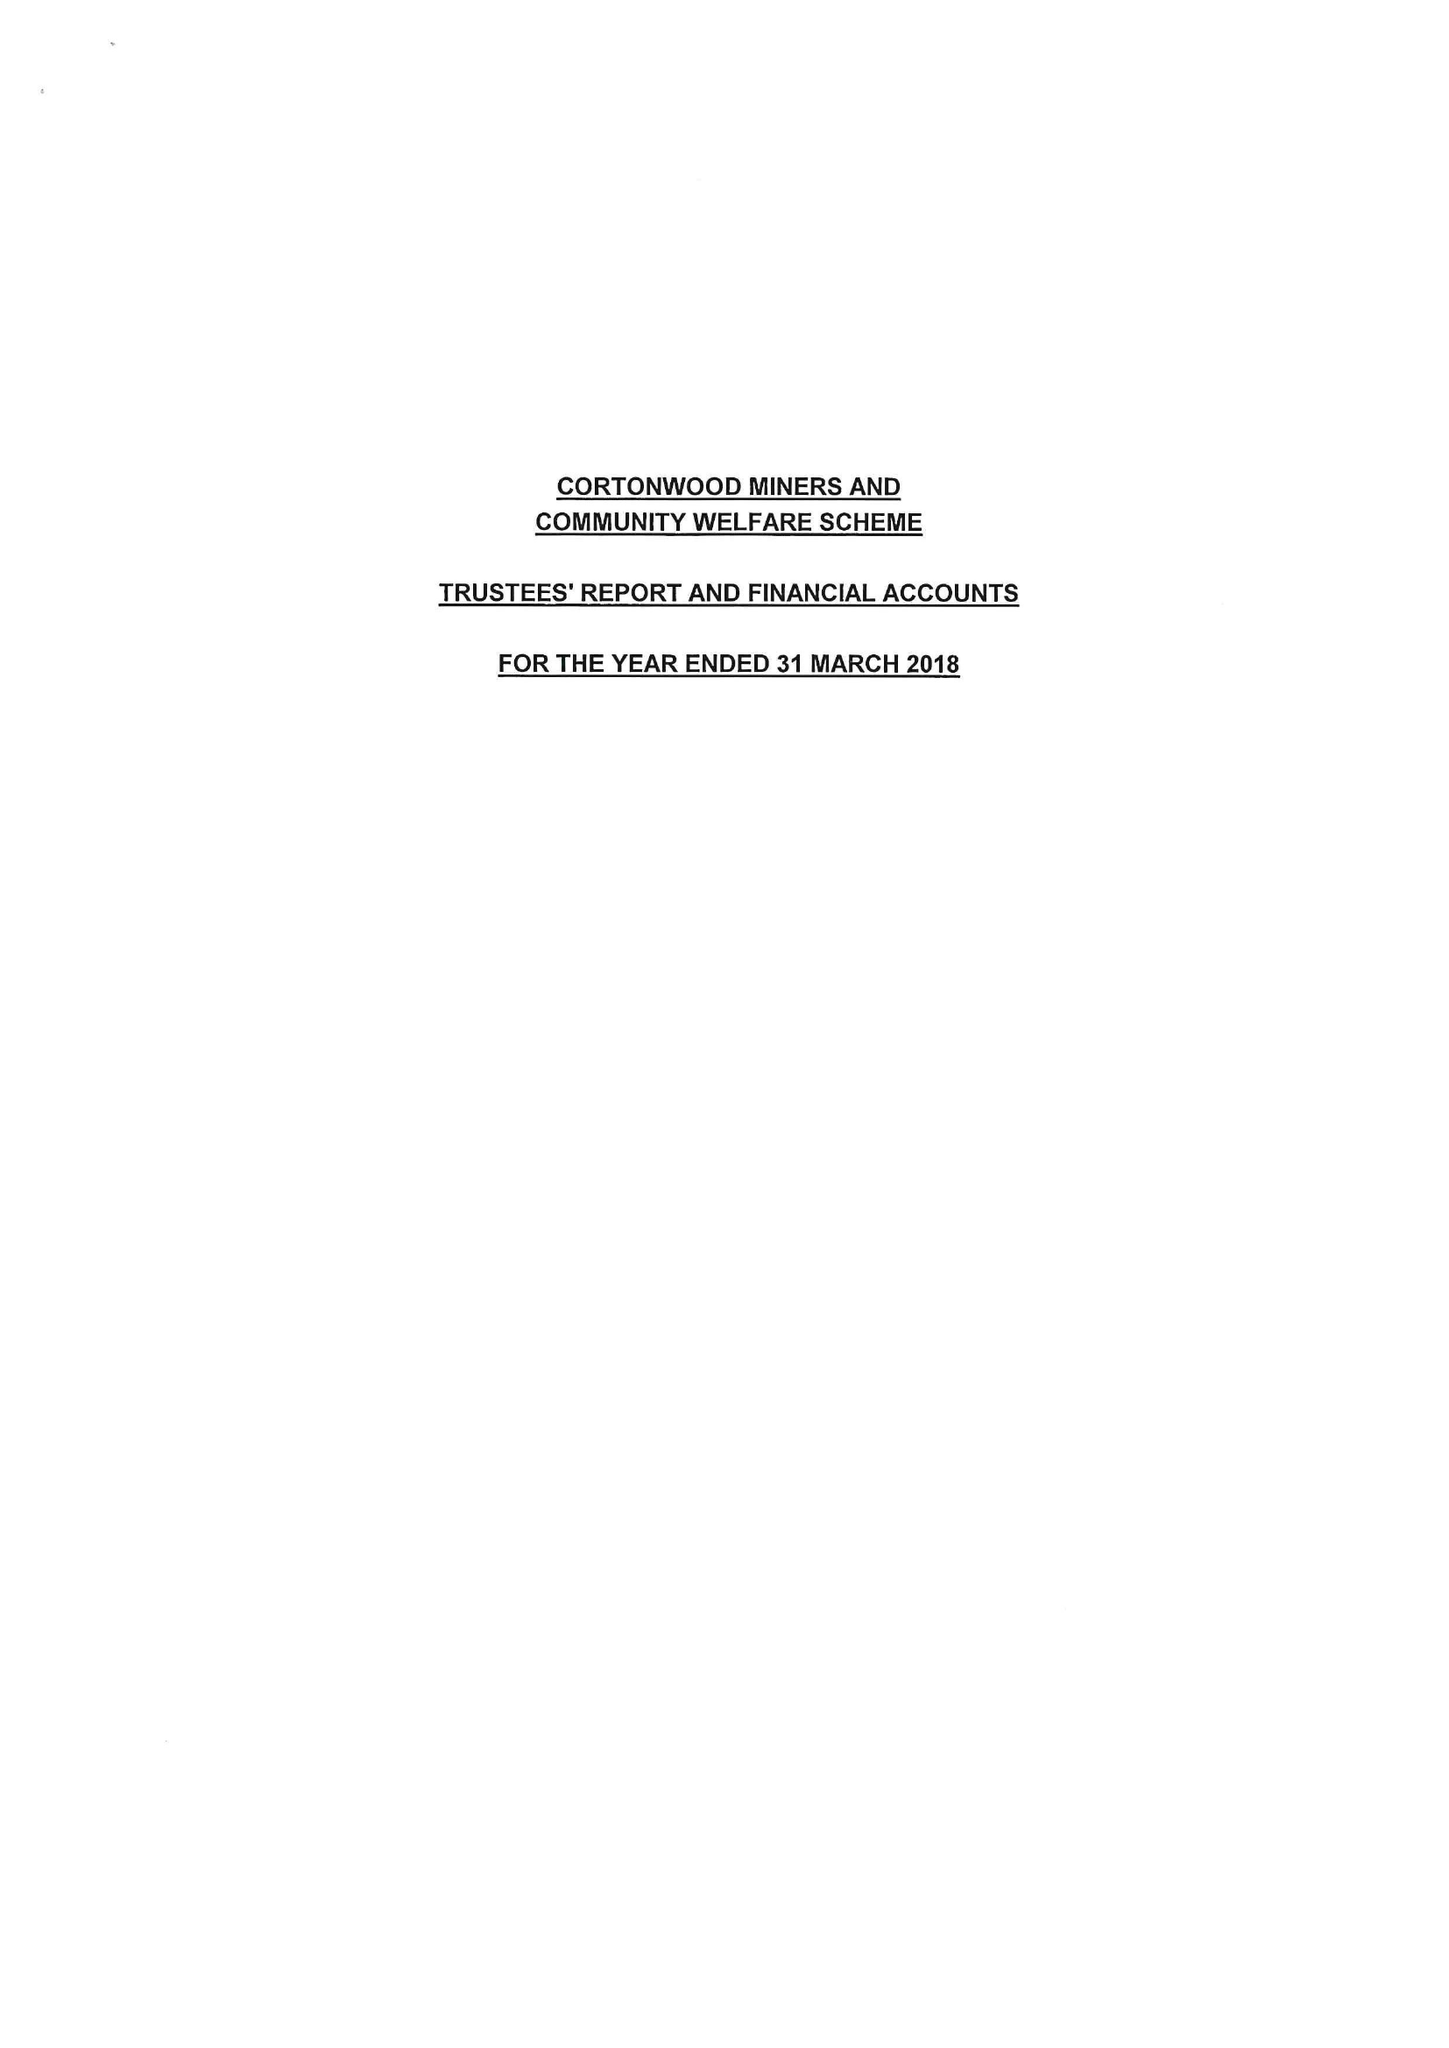What is the value for the spending_annually_in_british_pounds?
Answer the question using a single word or phrase. 50072.00 